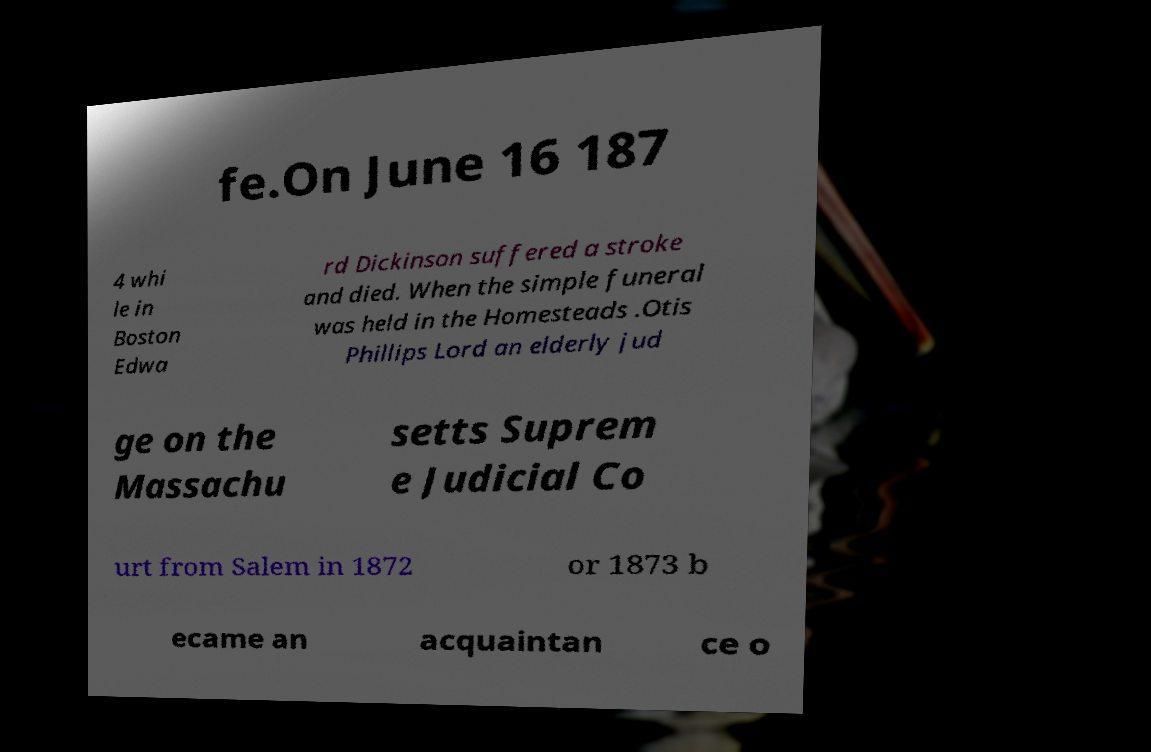For documentation purposes, I need the text within this image transcribed. Could you provide that? fe.On June 16 187 4 whi le in Boston Edwa rd Dickinson suffered a stroke and died. When the simple funeral was held in the Homesteads .Otis Phillips Lord an elderly jud ge on the Massachu setts Suprem e Judicial Co urt from Salem in 1872 or 1873 b ecame an acquaintan ce o 